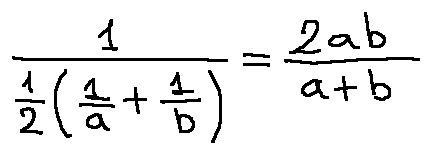Convert formula to latex. <formula><loc_0><loc_0><loc_500><loc_500>\frac { 1 } { \frac { 1 } { 2 } ( \frac { 1 } { a } + \frac { 1 } { b } ) } = \frac { 2 a b } { a + b }</formula> 